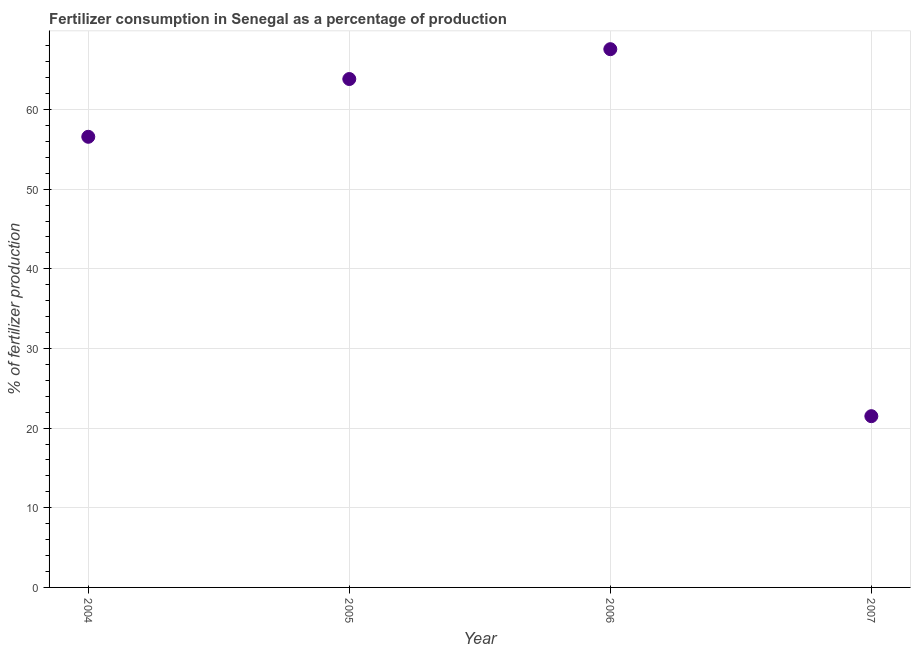What is the amount of fertilizer consumption in 2007?
Your response must be concise. 21.5. Across all years, what is the maximum amount of fertilizer consumption?
Provide a short and direct response. 67.58. Across all years, what is the minimum amount of fertilizer consumption?
Ensure brevity in your answer.  21.5. In which year was the amount of fertilizer consumption minimum?
Make the answer very short. 2007. What is the sum of the amount of fertilizer consumption?
Your answer should be very brief. 209.5. What is the difference between the amount of fertilizer consumption in 2006 and 2007?
Keep it short and to the point. 46.08. What is the average amount of fertilizer consumption per year?
Provide a succinct answer. 52.37. What is the median amount of fertilizer consumption?
Your answer should be very brief. 60.21. In how many years, is the amount of fertilizer consumption greater than 40 %?
Ensure brevity in your answer.  3. What is the ratio of the amount of fertilizer consumption in 2005 to that in 2006?
Your answer should be very brief. 0.94. Is the amount of fertilizer consumption in 2004 less than that in 2007?
Provide a succinct answer. No. Is the difference between the amount of fertilizer consumption in 2005 and 2006 greater than the difference between any two years?
Give a very brief answer. No. What is the difference between the highest and the second highest amount of fertilizer consumption?
Your answer should be very brief. 3.75. Is the sum of the amount of fertilizer consumption in 2004 and 2006 greater than the maximum amount of fertilizer consumption across all years?
Provide a succinct answer. Yes. What is the difference between the highest and the lowest amount of fertilizer consumption?
Offer a terse response. 46.08. Does the amount of fertilizer consumption monotonically increase over the years?
Provide a succinct answer. No. How many years are there in the graph?
Provide a succinct answer. 4. What is the difference between two consecutive major ticks on the Y-axis?
Give a very brief answer. 10. Are the values on the major ticks of Y-axis written in scientific E-notation?
Make the answer very short. No. Does the graph contain any zero values?
Make the answer very short. No. What is the title of the graph?
Give a very brief answer. Fertilizer consumption in Senegal as a percentage of production. What is the label or title of the Y-axis?
Give a very brief answer. % of fertilizer production. What is the % of fertilizer production in 2004?
Provide a short and direct response. 56.58. What is the % of fertilizer production in 2005?
Offer a very short reply. 63.83. What is the % of fertilizer production in 2006?
Give a very brief answer. 67.58. What is the % of fertilizer production in 2007?
Your answer should be compact. 21.5. What is the difference between the % of fertilizer production in 2004 and 2005?
Your response must be concise. -7.25. What is the difference between the % of fertilizer production in 2004 and 2006?
Your response must be concise. -11. What is the difference between the % of fertilizer production in 2004 and 2007?
Make the answer very short. 35.08. What is the difference between the % of fertilizer production in 2005 and 2006?
Keep it short and to the point. -3.75. What is the difference between the % of fertilizer production in 2005 and 2007?
Your response must be concise. 42.33. What is the difference between the % of fertilizer production in 2006 and 2007?
Your answer should be compact. 46.08. What is the ratio of the % of fertilizer production in 2004 to that in 2005?
Make the answer very short. 0.89. What is the ratio of the % of fertilizer production in 2004 to that in 2006?
Offer a terse response. 0.84. What is the ratio of the % of fertilizer production in 2004 to that in 2007?
Give a very brief answer. 2.63. What is the ratio of the % of fertilizer production in 2005 to that in 2006?
Keep it short and to the point. 0.94. What is the ratio of the % of fertilizer production in 2005 to that in 2007?
Provide a succinct answer. 2.97. What is the ratio of the % of fertilizer production in 2006 to that in 2007?
Your response must be concise. 3.14. 